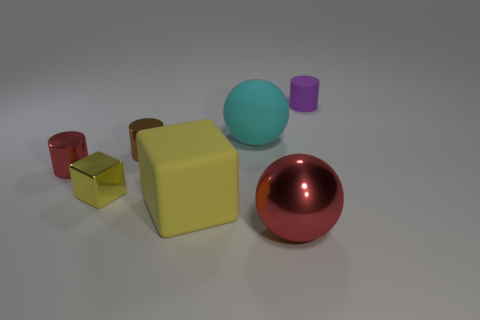Is the red cylinder made of the same material as the large object that is to the left of the cyan sphere?
Offer a very short reply. No. Is there anything else that has the same material as the tiny brown object?
Ensure brevity in your answer.  Yes. Is the number of tiny blue cylinders greater than the number of purple cylinders?
Give a very brief answer. No. What shape is the rubber object in front of the small shiny thing that is behind the red object left of the cyan matte thing?
Provide a succinct answer. Cube. Is the ball behind the small red shiny cylinder made of the same material as the yellow cube that is on the left side of the brown cylinder?
Provide a succinct answer. No. There is a tiny thing that is made of the same material as the big yellow thing; what is its shape?
Your answer should be compact. Cylinder. Is there any other thing of the same color as the large rubber block?
Offer a very short reply. Yes. What number of small shiny cylinders are there?
Provide a succinct answer. 2. What material is the red thing that is in front of the red thing that is left of the large cyan matte sphere?
Your response must be concise. Metal. There is a small metal cylinder behind the cylinder to the left of the block behind the yellow matte thing; what color is it?
Offer a very short reply. Brown. 